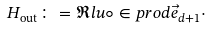Convert formula to latex. <formula><loc_0><loc_0><loc_500><loc_500>H _ { \text {out} } \colon = \Re l u \circ \in p r o d { \vec { e } _ { d + 1 } } { \cdot }</formula> 